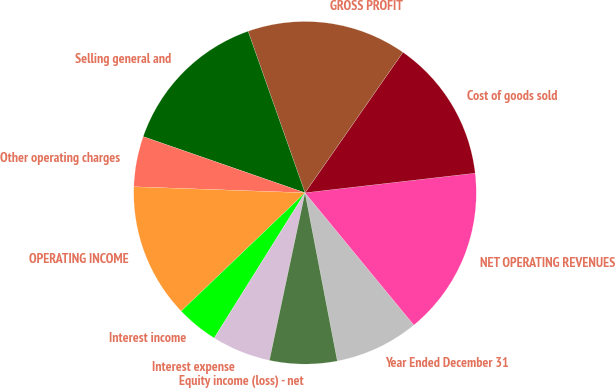Convert chart. <chart><loc_0><loc_0><loc_500><loc_500><pie_chart><fcel>Year Ended December 31<fcel>NET OPERATING REVENUES<fcel>Cost of goods sold<fcel>GROSS PROFIT<fcel>Selling general and<fcel>Other operating charges<fcel>OPERATING INCOME<fcel>Interest income<fcel>Interest expense<fcel>Equity income (loss) - net<nl><fcel>7.94%<fcel>15.87%<fcel>13.49%<fcel>15.08%<fcel>14.29%<fcel>4.76%<fcel>12.7%<fcel>3.97%<fcel>5.56%<fcel>6.35%<nl></chart> 